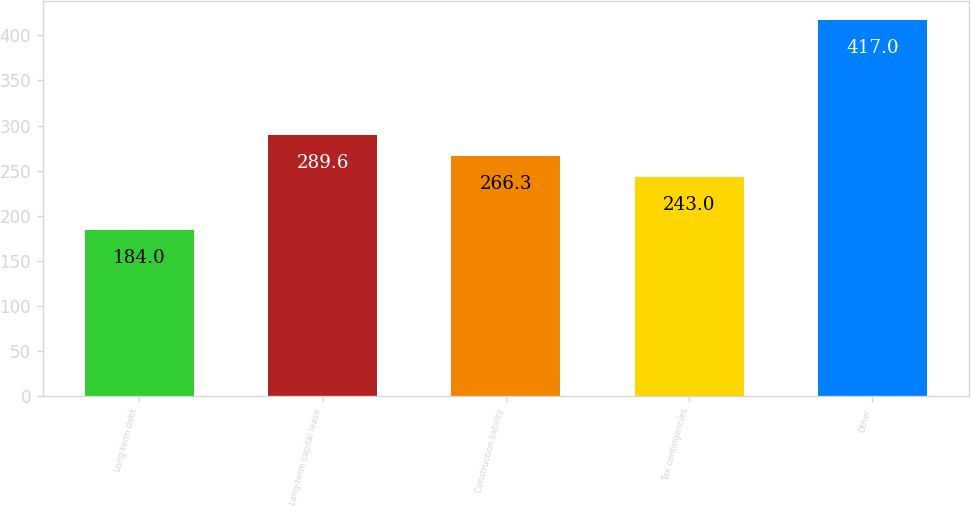Convert chart. <chart><loc_0><loc_0><loc_500><loc_500><bar_chart><fcel>Long-term debt<fcel>Long-term capital lease<fcel>Construction liability<fcel>Tax contingencies<fcel>Other<nl><fcel>184<fcel>289.6<fcel>266.3<fcel>243<fcel>417<nl></chart> 